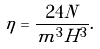Convert formula to latex. <formula><loc_0><loc_0><loc_500><loc_500>\eta = \frac { 2 4 N } { m ^ { 3 } H ^ { 3 } } .</formula> 